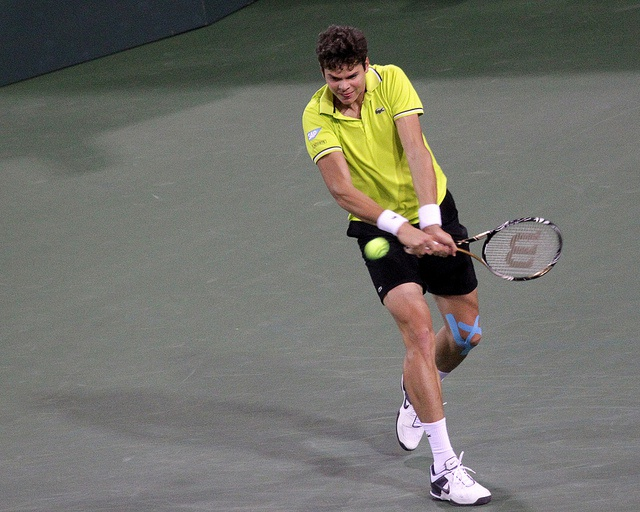Describe the objects in this image and their specific colors. I can see people in black, brown, khaki, and lavender tones, tennis racket in black, darkgray, and gray tones, and sports ball in black, khaki, and olive tones in this image. 